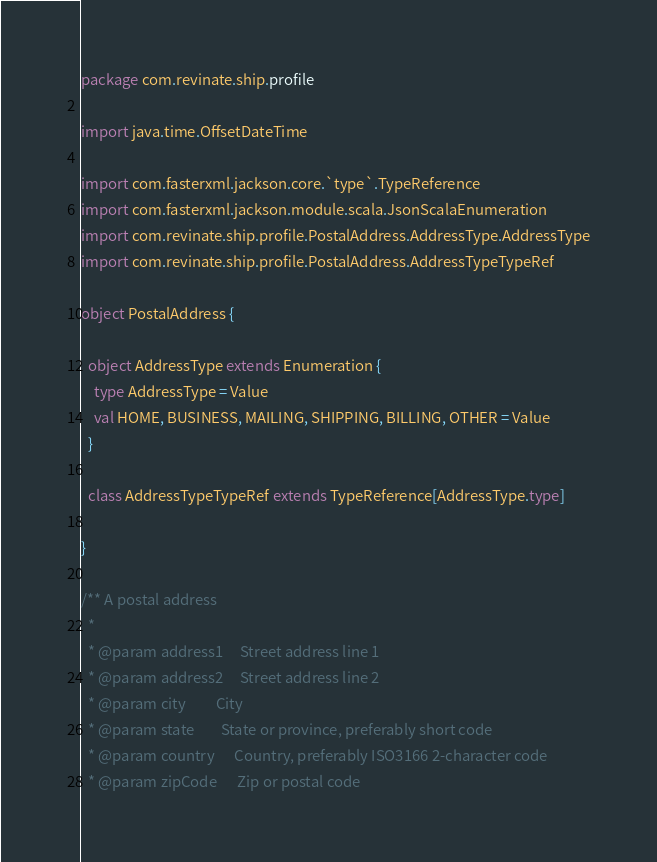Convert code to text. <code><loc_0><loc_0><loc_500><loc_500><_Scala_>package com.revinate.ship.profile

import java.time.OffsetDateTime

import com.fasterxml.jackson.core.`type`.TypeReference
import com.fasterxml.jackson.module.scala.JsonScalaEnumeration
import com.revinate.ship.profile.PostalAddress.AddressType.AddressType
import com.revinate.ship.profile.PostalAddress.AddressTypeTypeRef

object PostalAddress {

  object AddressType extends Enumeration {
    type AddressType = Value
    val HOME, BUSINESS, MAILING, SHIPPING, BILLING, OTHER = Value
  }

  class AddressTypeTypeRef extends TypeReference[AddressType.type]

}

/** A postal address
  *
  * @param address1     Street address line 1
  * @param address2     Street address line 2
  * @param city         City
  * @param state        State or province, preferably short code
  * @param country      Country, preferably ISO3166 2-character code
  * @param zipCode      Zip or postal code</code> 